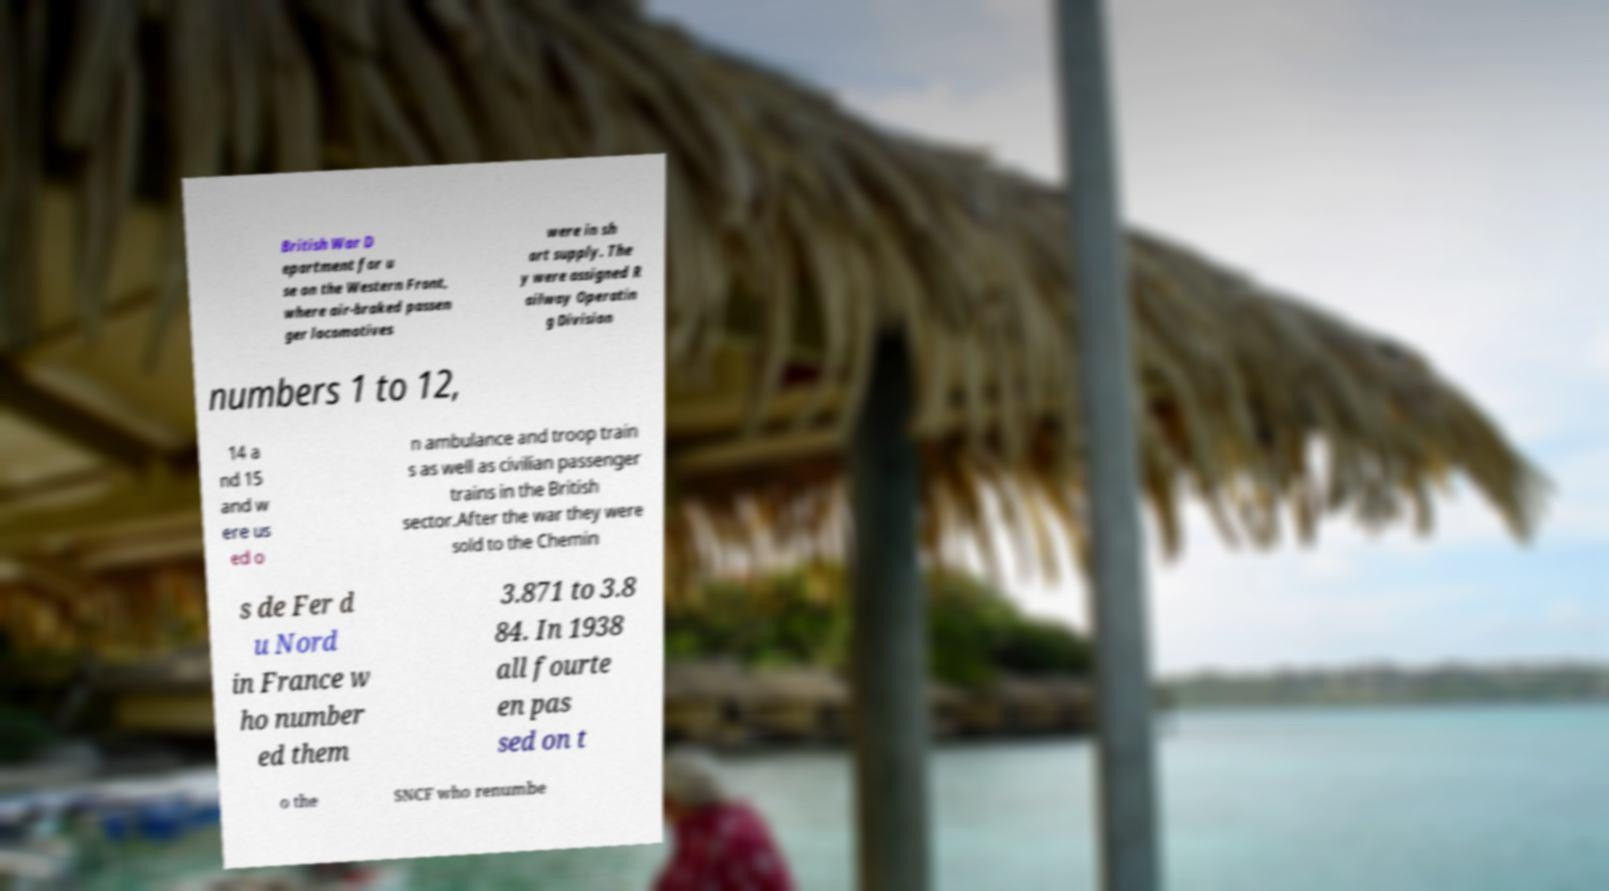Can you read and provide the text displayed in the image?This photo seems to have some interesting text. Can you extract and type it out for me? British War D epartment for u se on the Western Front, where air-braked passen ger locomotives were in sh ort supply. The y were assigned R ailway Operatin g Division numbers 1 to 12, 14 a nd 15 and w ere us ed o n ambulance and troop train s as well as civilian passenger trains in the British sector.After the war they were sold to the Chemin s de Fer d u Nord in France w ho number ed them 3.871 to 3.8 84. In 1938 all fourte en pas sed on t o the SNCF who renumbe 